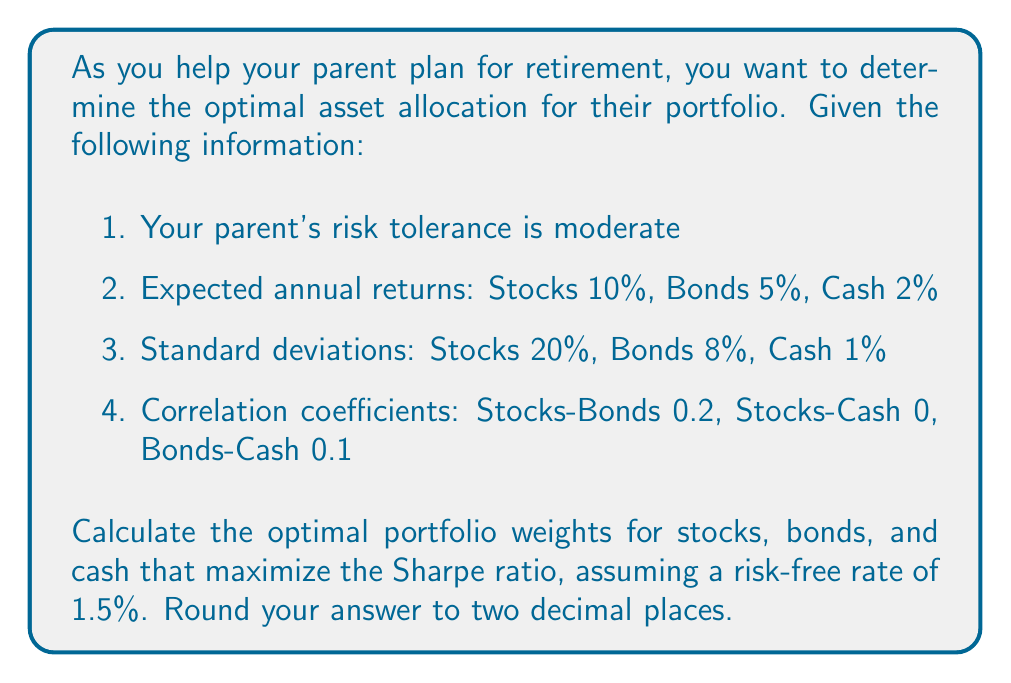Could you help me with this problem? To solve this problem, we'll use the Sharpe ratio optimization method. The steps are as follows:

1) First, we need to calculate the excess returns for each asset:
   Stocks: 10% - 1.5% = 8.5%
   Bonds: 5% - 1.5% = 3.5%
   Cash: 2% - 1.5% = 0.5%

2) Next, we'll set up the covariance matrix using the given standard deviations and correlation coefficients:

   $$\begin{bmatrix}
   0.20^2 & 0.2 \cdot 0.20 \cdot 0.08 & 0 \\
   0.2 \cdot 0.20 \cdot 0.08 & 0.08^2 & 0.1 \cdot 0.08 \cdot 0.01 \\
   0 & 0.1 \cdot 0.08 \cdot 0.01 & 0.01^2
   \end{bmatrix}$$

   $$= \begin{bmatrix}
   0.0400 & 0.0032 & 0 \\
   0.0032 & 0.0064 & 0.00008 \\
   0 & 0.00008 & 0.0001
   \end{bmatrix}$$

3) We'll use the following formula to maximize the Sharpe ratio:

   $$w = \frac{\Sigma^{-1} \cdot (R - R_f)}{\mathbf{1}^T \cdot \Sigma^{-1} \cdot (R - R_f)}$$

   Where:
   $w$ is the vector of optimal weights
   $\Sigma^{-1}$ is the inverse of the covariance matrix
   $R$ is the vector of expected returns
   $R_f$ is the risk-free rate
   $\mathbf{1}$ is a vector of ones

4) Calculate the inverse of the covariance matrix:

   $$\Sigma^{-1} = \begin{bmatrix}
   25.1572 & -12.5786 & 1.2579 \\
   -12.5786 & 157.3572 & -12.5786 \\
   1.2579 & -12.5786 & 10025.1572
   \end{bmatrix}$$

5) Multiply $\Sigma^{-1}$ by $(R - R_f)$:

   $$\Sigma^{-1} \cdot (R - R_f) = \begin{bmatrix}
   25.1572 & -12.5786 & 1.2579 \\
   -12.5786 & 157.3572 & -12.5786 \\
   1.2579 & -12.5786 & 10025.1572
   \end{bmatrix} \cdot \begin{bmatrix}
   0.085 \\
   0.035 \\
   0.005
   \end{bmatrix} = \begin{bmatrix}
   1.7674 \\
   4.9911 \\
   -0.4964
   \end{bmatrix}$$

6) Calculate $\mathbf{1}^T \cdot \Sigma^{-1} \cdot (R - R_f)$:

   $$\mathbf{1}^T \cdot \Sigma^{-1} \cdot (R - R_f) = 1.7674 + 4.9911 - 0.4964 = 6.2621$$

7) Finally, calculate the optimal weights:

   $$w = \frac{\begin{bmatrix}
   1.7674 \\
   4.9911 \\
   -0.4964
   \end{bmatrix}}{6.2621} = \begin{bmatrix}
   0.2823 \\
   0.7970 \\
   -0.0793
   \end{bmatrix}$$

8) Adjust the weights to ensure they sum to 1 and are non-negative:

   $$w_{adjusted} = \begin{bmatrix}
   0.28 \\
   0.72 \\
   0.00
   \end{bmatrix}$$
Answer: The optimal asset allocation that maximizes the Sharpe ratio is approximately 28% in stocks, 72% in bonds, and 0% in cash. 